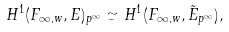Convert formula to latex. <formula><loc_0><loc_0><loc_500><loc_500>H ^ { 1 } ( F _ { \infty , w } , E ) _ { p ^ { \infty } } \simeq H ^ { 1 } ( F _ { \infty , w } , \tilde { E } _ { p ^ { \infty } } ) ,</formula> 